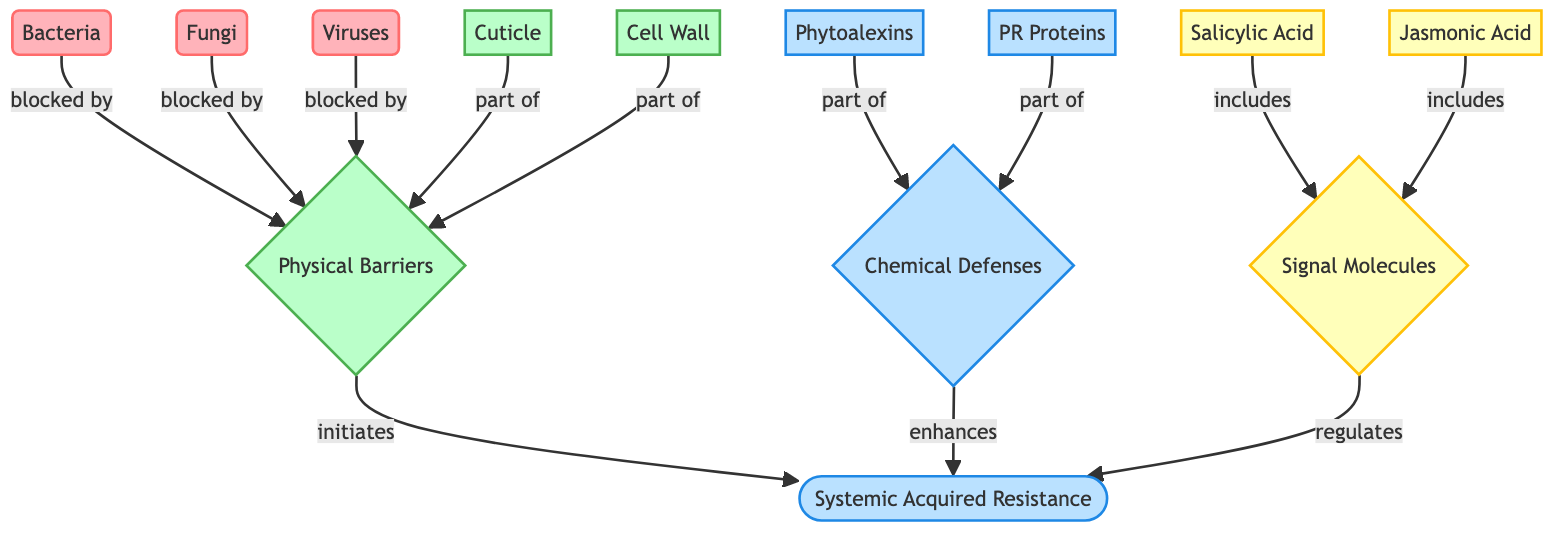What are the three types of common plant pathogens? The diagram identifies three types of plant pathogens: bacteria, fungi, and viruses, which are specifically labeled as pathogens and are colored distinctly to emphasize their role in plant diseases.
Answer: bacteria, fungi, viruses What do physical barriers consist of? The diagram indicates that physical barriers are made up of two components: the cuticle and the cell wall, which are specifically highlighted under the category of physical barriers.
Answer: cuticle, cell wall How many types of chemical defenses are there? The diagram categorizes chemical defenses into two types: phytoalexins and PR proteins. This information can be counted directly from the labeled nodes under chemical defenses.
Answer: 2 Which signal molecules regulate systemic acquired resistance? The diagram specifies that salicylic acid and jasmonic acid are the signal molecules that regulate systemic acquired resistance, clearly indicating their roles through the connections shown in the diagram.
Answer: salicylic acid, jasmonic acid What is the relationship between physical barriers and systemic acquired resistance? The diagram shows an arrow indicating that physical barriers initiate systemic acquired resistance, meaning that the presence of physical barriers like cuticle and cell wall leads to the activation of systemic acquired resistance mechanisms in plants.
Answer: initiates How do chemical defenses contribute to systemic acquired resistance? The diagram illustrates that chemical defenses enhance systemic acquired resistance, indicating a supportive role where chemical compounds like phytoalexins and PR proteins help strengthen the plant's overall immune response.
Answer: enhances How are signal molecules described in relation to systemic acquired resistance? The diagram states that signal molecules regulate systemic acquired resistance, demonstrating an active role where signal transduction from these molecules leads to the activation of plant defense mechanisms.
Answer: regulates What is the role of phytoalexins in the immune response? The diagram places phytoalexins within chemical defenses, which suggests their role as a component that contributes to strengthening the plant's defense response against pathogens.
Answer: part of chemical defenses Which node represents the structure that blocks pathogens physically? The physical barriers node in the diagram represents structures that block pathogens, and it specifically mentions cuticle and cell wall as the primary components that provide this defense.
Answer: physical barriers 